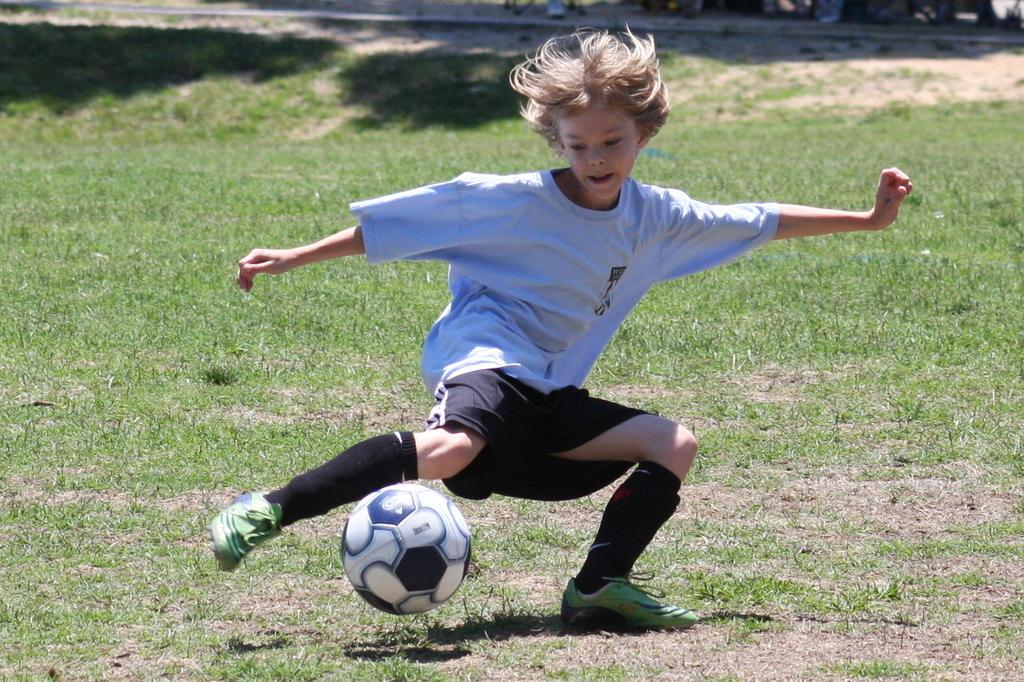Who is the main subject in the image? There is a boy in the image. What is the boy doing in the image? The boy is playing with a football. What object is the boy playing with? There is a ball in the image, which is a football. What type of surface is the boy playing on? There is grass on the ground in the image. What type of fuel is the boy using to power his play in the image? There is no mention of fuel in the image, as the boy is playing with a football on grass. 